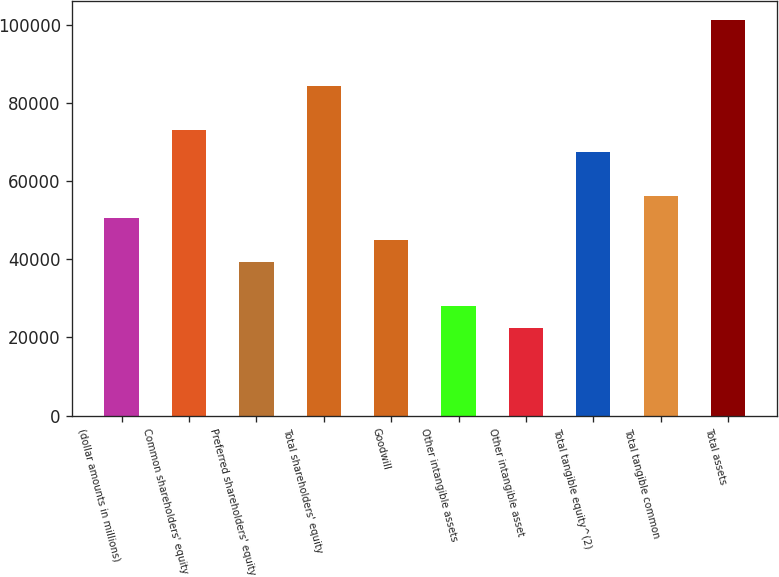<chart> <loc_0><loc_0><loc_500><loc_500><bar_chart><fcel>(dollar amounts in millions)<fcel>Common shareholders' equity<fcel>Preferred shareholders' equity<fcel>Total shareholders' equity<fcel>Goodwill<fcel>Other intangible assets<fcel>Other intangible asset<fcel>Total tangible equity^(2)<fcel>Total tangible common<fcel>Total assets<nl><fcel>50527.8<fcel>72980.7<fcel>39301.3<fcel>84207.2<fcel>44914.6<fcel>28074.9<fcel>22461.7<fcel>67367.5<fcel>56141<fcel>101047<nl></chart> 